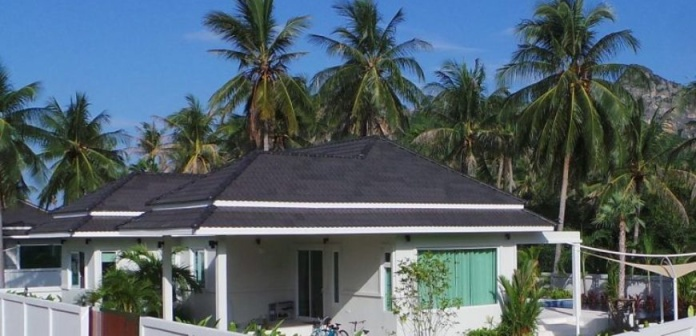What's happening in the scene? The image features a picturesque tropical scene centered around a charming white bungalow with a contrasting black roof. Green shutters bring a pop of color to the property. There's a quaint garden enclosed by a white picket fence in which two bicycles are parked, suggesting the presence of residents or visitors enjoying a serene getaway. Surrounding the bungalow are numerous palm trees softly swaying, with mist-covered mountains rising majestically in the distance. The composition of elements like the house, the bicycles, and the natural surroundings highlights a tranquil and inviting atmosphere, perfect for relaxation or a holiday escape. 